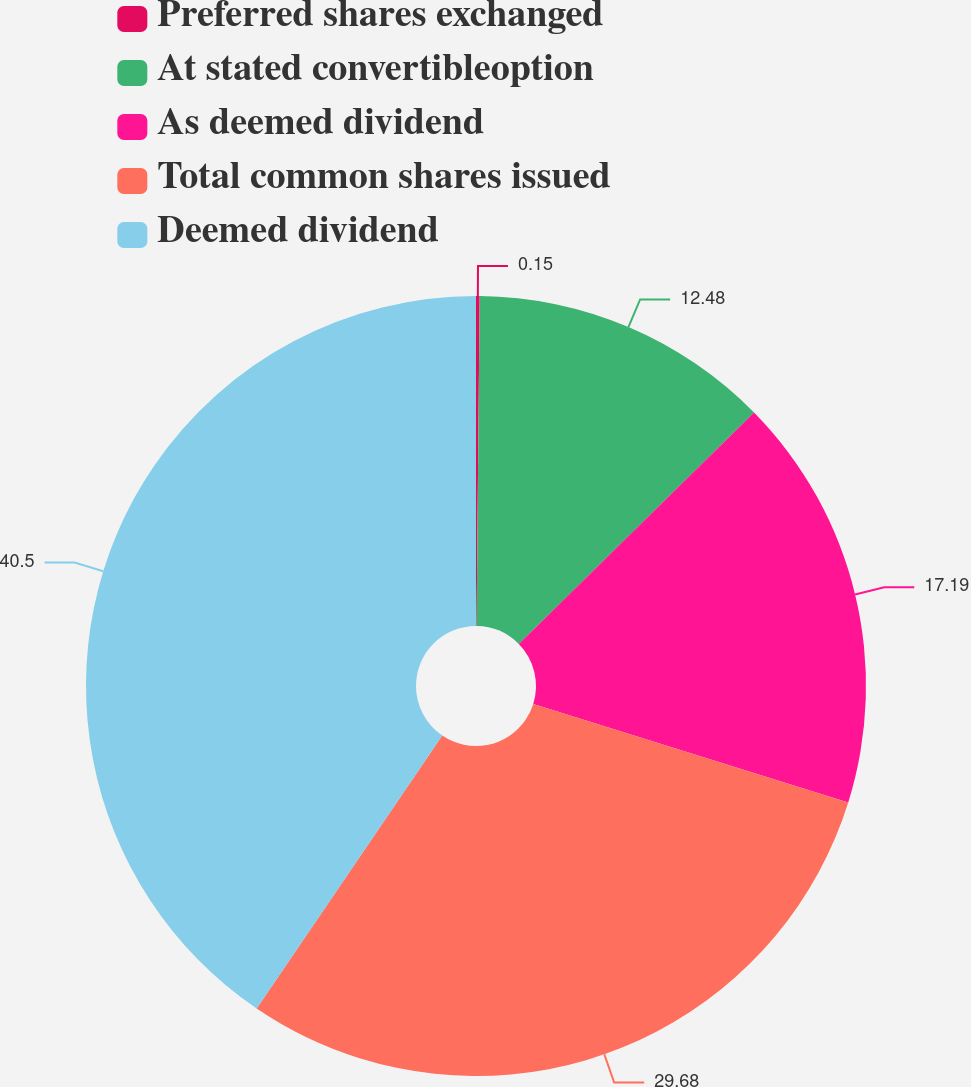Convert chart to OTSL. <chart><loc_0><loc_0><loc_500><loc_500><pie_chart><fcel>Preferred shares exchanged<fcel>At stated convertibleoption<fcel>As deemed dividend<fcel>Total common shares issued<fcel>Deemed dividend<nl><fcel>0.15%<fcel>12.48%<fcel>17.19%<fcel>29.68%<fcel>40.49%<nl></chart> 